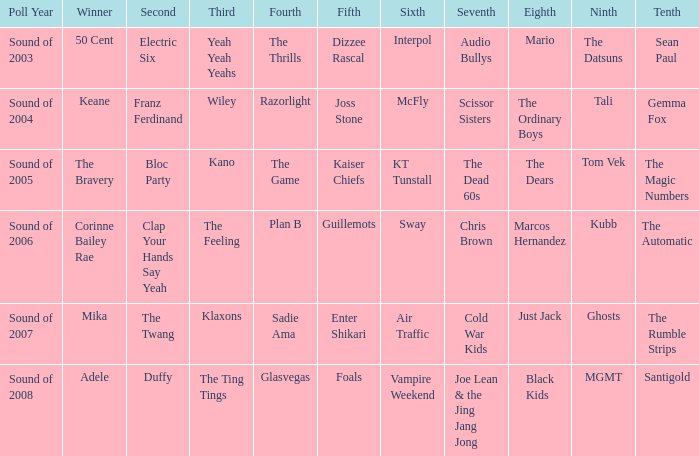How many times was Plan B 4th place? 1.0. 